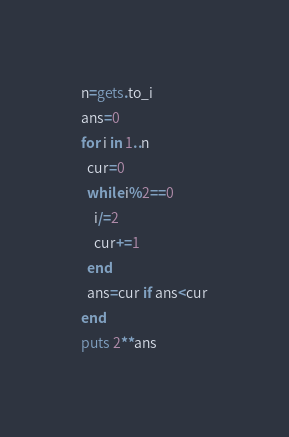Convert code to text. <code><loc_0><loc_0><loc_500><loc_500><_Ruby_>n=gets.to_i
ans=0
for i in 1..n
  cur=0
  while i%2==0
    i/=2
    cur+=1
  end
  ans=cur if ans<cur
end
puts 2**ans
</code> 